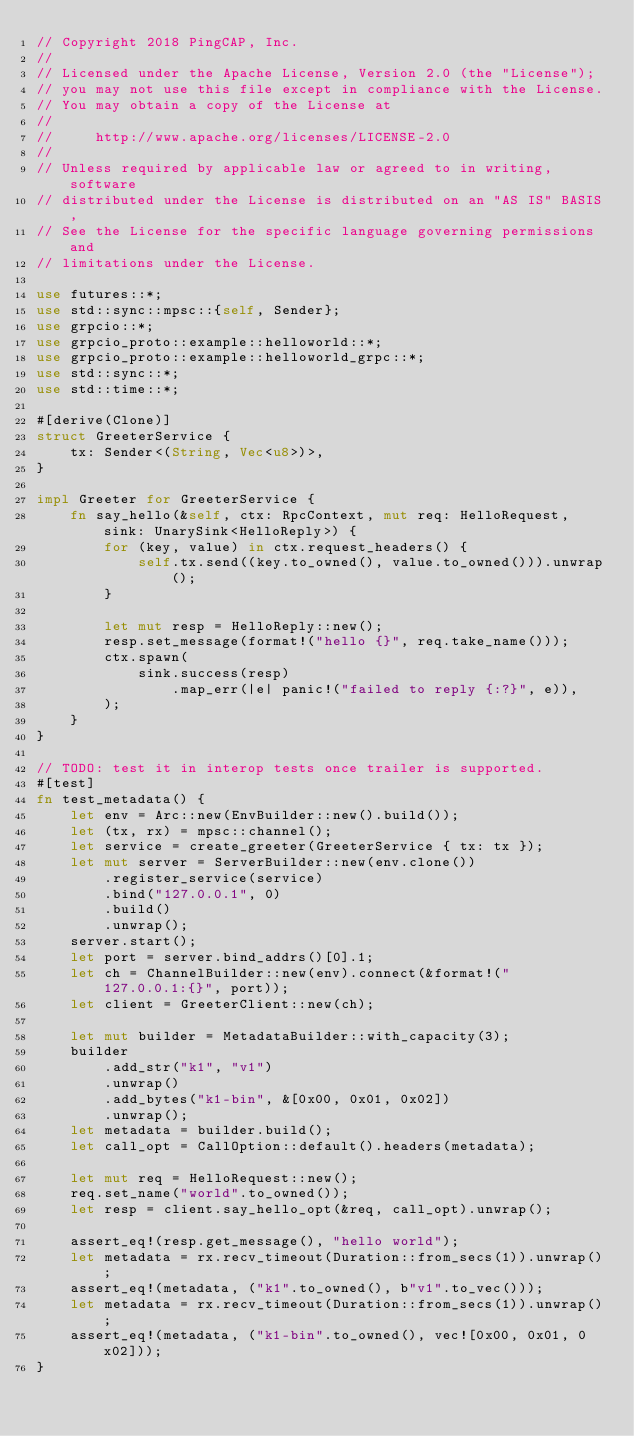<code> <loc_0><loc_0><loc_500><loc_500><_Rust_>// Copyright 2018 PingCAP, Inc.
//
// Licensed under the Apache License, Version 2.0 (the "License");
// you may not use this file except in compliance with the License.
// You may obtain a copy of the License at
//
//     http://www.apache.org/licenses/LICENSE-2.0
//
// Unless required by applicable law or agreed to in writing, software
// distributed under the License is distributed on an "AS IS" BASIS,
// See the License for the specific language governing permissions and
// limitations under the License.

use futures::*;
use std::sync::mpsc::{self, Sender};
use grpcio::*;
use grpcio_proto::example::helloworld::*;
use grpcio_proto::example::helloworld_grpc::*;
use std::sync::*;
use std::time::*;

#[derive(Clone)]
struct GreeterService {
    tx: Sender<(String, Vec<u8>)>,
}

impl Greeter for GreeterService {
    fn say_hello(&self, ctx: RpcContext, mut req: HelloRequest, sink: UnarySink<HelloReply>) {
        for (key, value) in ctx.request_headers() {
            self.tx.send((key.to_owned(), value.to_owned())).unwrap();
        }

        let mut resp = HelloReply::new();
        resp.set_message(format!("hello {}", req.take_name()));
        ctx.spawn(
            sink.success(resp)
                .map_err(|e| panic!("failed to reply {:?}", e)),
        );
    }
}

// TODO: test it in interop tests once trailer is supported.
#[test]
fn test_metadata() {
    let env = Arc::new(EnvBuilder::new().build());
    let (tx, rx) = mpsc::channel();
    let service = create_greeter(GreeterService { tx: tx });
    let mut server = ServerBuilder::new(env.clone())
        .register_service(service)
        .bind("127.0.0.1", 0)
        .build()
        .unwrap();
    server.start();
    let port = server.bind_addrs()[0].1;
    let ch = ChannelBuilder::new(env).connect(&format!("127.0.0.1:{}", port));
    let client = GreeterClient::new(ch);

    let mut builder = MetadataBuilder::with_capacity(3);
    builder
        .add_str("k1", "v1")
        .unwrap()
        .add_bytes("k1-bin", &[0x00, 0x01, 0x02])
        .unwrap();
    let metadata = builder.build();
    let call_opt = CallOption::default().headers(metadata);

    let mut req = HelloRequest::new();
    req.set_name("world".to_owned());
    let resp = client.say_hello_opt(&req, call_opt).unwrap();

    assert_eq!(resp.get_message(), "hello world");
    let metadata = rx.recv_timeout(Duration::from_secs(1)).unwrap();
    assert_eq!(metadata, ("k1".to_owned(), b"v1".to_vec()));
    let metadata = rx.recv_timeout(Duration::from_secs(1)).unwrap();
    assert_eq!(metadata, ("k1-bin".to_owned(), vec![0x00, 0x01, 0x02]));
}
</code> 